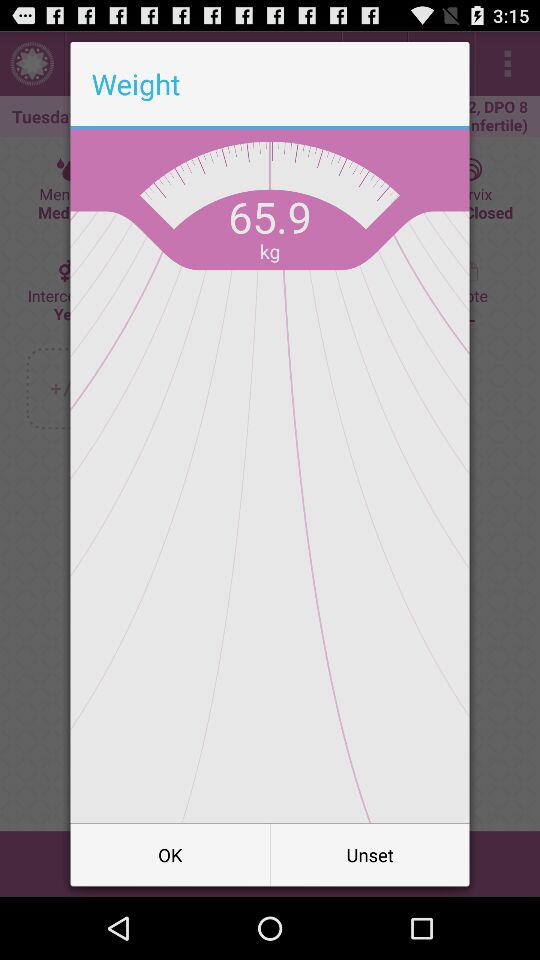What is the weight? The weight is 65.9 kg. 